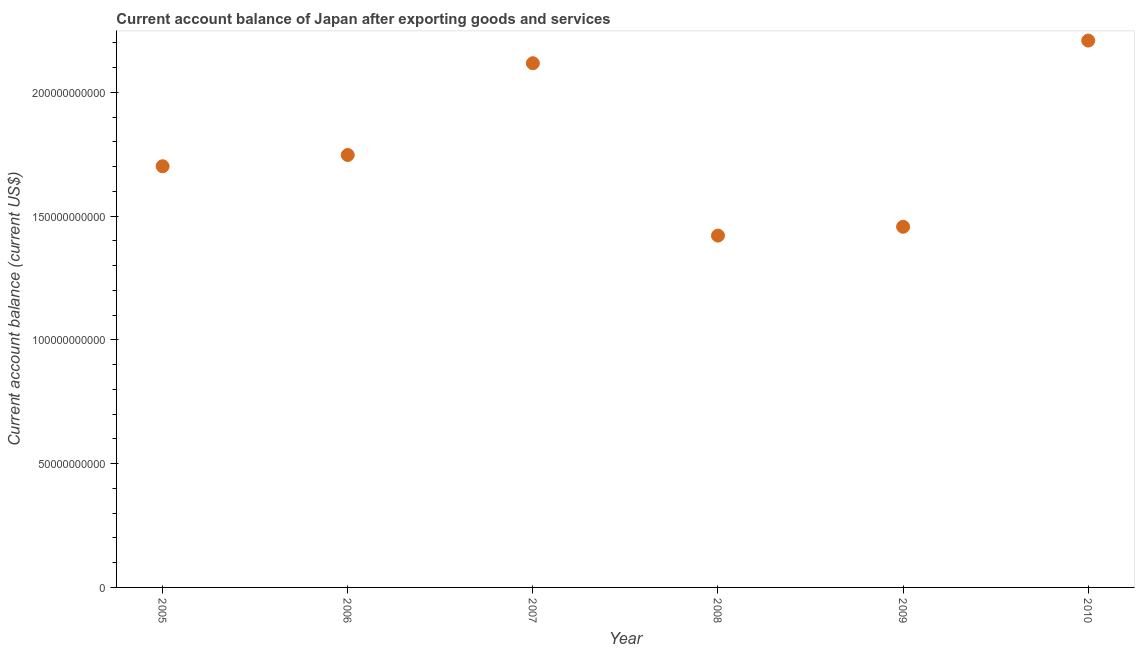What is the current account balance in 2008?
Provide a short and direct response. 1.42e+11. Across all years, what is the maximum current account balance?
Ensure brevity in your answer.  2.21e+11. Across all years, what is the minimum current account balance?
Offer a terse response. 1.42e+11. In which year was the current account balance minimum?
Keep it short and to the point. 2008. What is the sum of the current account balance?
Your response must be concise. 1.07e+12. What is the difference between the current account balance in 2006 and 2010?
Your response must be concise. -4.62e+1. What is the average current account balance per year?
Ensure brevity in your answer.  1.78e+11. What is the median current account balance?
Provide a short and direct response. 1.72e+11. Do a majority of the years between 2005 and 2007 (inclusive) have current account balance greater than 190000000000 US$?
Your answer should be compact. No. What is the ratio of the current account balance in 2007 to that in 2010?
Your response must be concise. 0.96. Is the current account balance in 2007 less than that in 2009?
Provide a short and direct response. No. Is the difference between the current account balance in 2005 and 2008 greater than the difference between any two years?
Provide a short and direct response. No. What is the difference between the highest and the second highest current account balance?
Your answer should be very brief. 9.15e+09. What is the difference between the highest and the lowest current account balance?
Provide a succinct answer. 7.88e+1. What is the difference between two consecutive major ticks on the Y-axis?
Provide a succinct answer. 5.00e+1. Are the values on the major ticks of Y-axis written in scientific E-notation?
Provide a short and direct response. No. Does the graph contain any zero values?
Keep it short and to the point. No. What is the title of the graph?
Give a very brief answer. Current account balance of Japan after exporting goods and services. What is the label or title of the X-axis?
Offer a very short reply. Year. What is the label or title of the Y-axis?
Make the answer very short. Current account balance (current US$). What is the Current account balance (current US$) in 2005?
Provide a succinct answer. 1.70e+11. What is the Current account balance (current US$) in 2006?
Make the answer very short. 1.75e+11. What is the Current account balance (current US$) in 2007?
Give a very brief answer. 2.12e+11. What is the Current account balance (current US$) in 2008?
Provide a short and direct response. 1.42e+11. What is the Current account balance (current US$) in 2009?
Your answer should be compact. 1.46e+11. What is the Current account balance (current US$) in 2010?
Your response must be concise. 2.21e+11. What is the difference between the Current account balance (current US$) in 2005 and 2006?
Provide a short and direct response. -4.55e+09. What is the difference between the Current account balance (current US$) in 2005 and 2007?
Your answer should be very brief. -4.16e+1. What is the difference between the Current account balance (current US$) in 2005 and 2008?
Offer a terse response. 2.80e+1. What is the difference between the Current account balance (current US$) in 2005 and 2009?
Your answer should be very brief. 2.44e+1. What is the difference between the Current account balance (current US$) in 2005 and 2010?
Your answer should be very brief. -5.08e+1. What is the difference between the Current account balance (current US$) in 2006 and 2007?
Your answer should be very brief. -3.71e+1. What is the difference between the Current account balance (current US$) in 2006 and 2008?
Make the answer very short. 3.26e+1. What is the difference between the Current account balance (current US$) in 2006 and 2009?
Provide a short and direct response. 2.90e+1. What is the difference between the Current account balance (current US$) in 2006 and 2010?
Keep it short and to the point. -4.62e+1. What is the difference between the Current account balance (current US$) in 2007 and 2008?
Keep it short and to the point. 6.96e+1. What is the difference between the Current account balance (current US$) in 2007 and 2009?
Offer a very short reply. 6.61e+1. What is the difference between the Current account balance (current US$) in 2007 and 2010?
Your answer should be compact. -9.15e+09. What is the difference between the Current account balance (current US$) in 2008 and 2009?
Ensure brevity in your answer.  -3.56e+09. What is the difference between the Current account balance (current US$) in 2008 and 2010?
Your answer should be compact. -7.88e+1. What is the difference between the Current account balance (current US$) in 2009 and 2010?
Your response must be concise. -7.52e+1. What is the ratio of the Current account balance (current US$) in 2005 to that in 2007?
Provide a short and direct response. 0.8. What is the ratio of the Current account balance (current US$) in 2005 to that in 2008?
Offer a terse response. 1.2. What is the ratio of the Current account balance (current US$) in 2005 to that in 2009?
Provide a short and direct response. 1.17. What is the ratio of the Current account balance (current US$) in 2005 to that in 2010?
Offer a terse response. 0.77. What is the ratio of the Current account balance (current US$) in 2006 to that in 2007?
Give a very brief answer. 0.82. What is the ratio of the Current account balance (current US$) in 2006 to that in 2008?
Provide a succinct answer. 1.23. What is the ratio of the Current account balance (current US$) in 2006 to that in 2009?
Offer a terse response. 1.2. What is the ratio of the Current account balance (current US$) in 2006 to that in 2010?
Offer a terse response. 0.79. What is the ratio of the Current account balance (current US$) in 2007 to that in 2008?
Keep it short and to the point. 1.49. What is the ratio of the Current account balance (current US$) in 2007 to that in 2009?
Provide a short and direct response. 1.45. What is the ratio of the Current account balance (current US$) in 2007 to that in 2010?
Your answer should be very brief. 0.96. What is the ratio of the Current account balance (current US$) in 2008 to that in 2010?
Your answer should be compact. 0.64. What is the ratio of the Current account balance (current US$) in 2009 to that in 2010?
Keep it short and to the point. 0.66. 